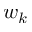<formula> <loc_0><loc_0><loc_500><loc_500>w _ { k }</formula> 